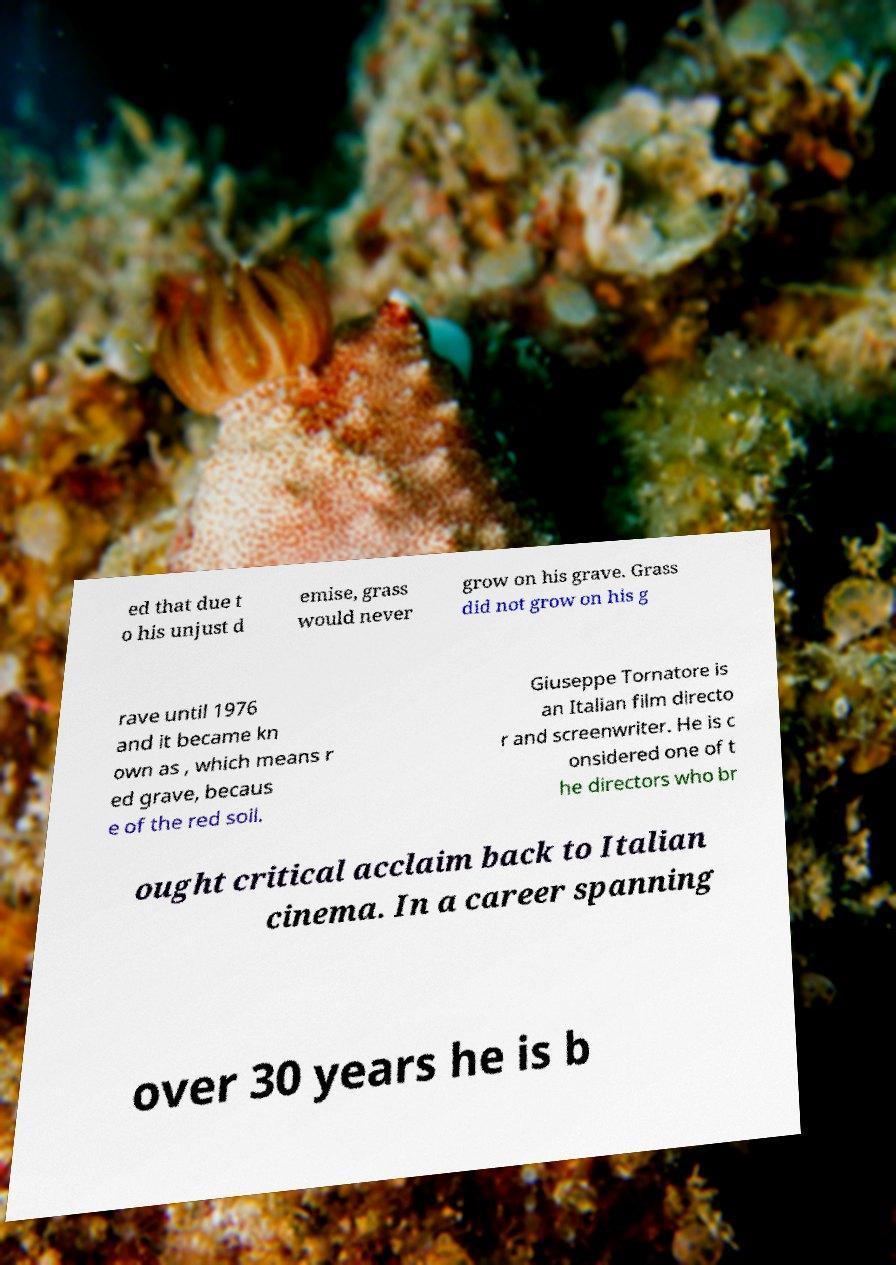I need the written content from this picture converted into text. Can you do that? ed that due t o his unjust d emise, grass would never grow on his grave. Grass did not grow on his g rave until 1976 and it became kn own as , which means r ed grave, becaus e of the red soil. Giuseppe Tornatore is an Italian film directo r and screenwriter. He is c onsidered one of t he directors who br ought critical acclaim back to Italian cinema. In a career spanning over 30 years he is b 